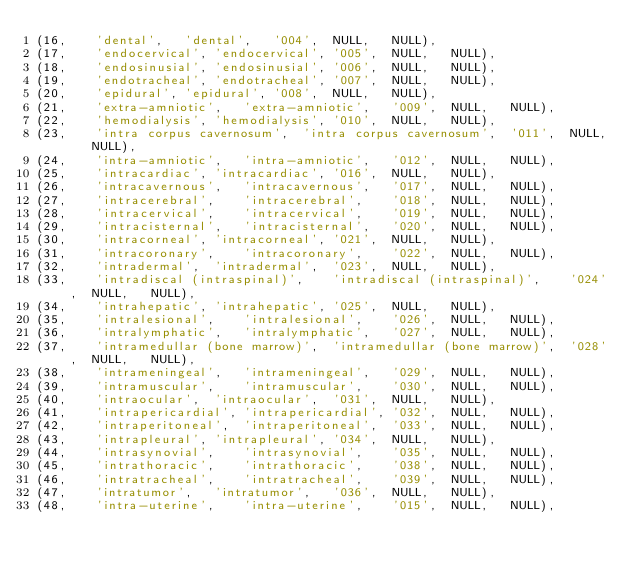<code> <loc_0><loc_0><loc_500><loc_500><_SQL_>(16,	'dental',	'dental',	'004',	NULL,	NULL),
(17,	'endocervical',	'endocervical',	'005',	NULL,	NULL),
(18,	'endosinusial',	'endosinusial',	'006',	NULL,	NULL),
(19,	'endotracheal',	'endotracheal',	'007',	NULL,	NULL),
(20,	'epidural',	'epidural',	'008',	NULL,	NULL),
(21,	'extra-amniotic',	'extra-amniotic',	'009',	NULL,	NULL),
(22,	'hemodialysis',	'hemodialysis',	'010',	NULL,	NULL),
(23,	'intra corpus cavernosum',	'intra corpus cavernosum',	'011',	NULL,	NULL),
(24,	'intra-amniotic',	'intra-amniotic',	'012',	NULL,	NULL),
(25,	'intracardiac',	'intracardiac',	'016',	NULL,	NULL),
(26,	'intracavernous',	'intracavernous',	'017',	NULL,	NULL),
(27,	'intracerebral',	'intracerebral',	'018',	NULL,	NULL),
(28,	'intracervical',	'intracervical',	'019',	NULL,	NULL),
(29,	'intracisternal',	'intracisternal',	'020',	NULL,	NULL),
(30,	'intracorneal',	'intracorneal',	'021',	NULL,	NULL),
(31,	'intracoronary',	'intracoronary',	'022',	NULL,	NULL),
(32,	'intradermal',	'intradermal',	'023',	NULL,	NULL),
(33,	'intradiscal (intraspinal)',	'intradiscal (intraspinal)',	'024',	NULL,	NULL),
(34,	'intrahepatic',	'intrahepatic',	'025',	NULL,	NULL),
(35,	'intralesional',	'intralesional',	'026',	NULL,	NULL),
(36,	'intralymphatic',	'intralymphatic',	'027',	NULL,	NULL),
(37,	'intramedullar (bone marrow)',	'intramedullar (bone marrow)',	'028',	NULL,	NULL),
(38,	'intrameningeal',	'intrameningeal',	'029',	NULL,	NULL),
(39,	'intramuscular',	'intramuscular',	'030',	NULL,	NULL),
(40,	'intraocular',	'intraocular',	'031',	NULL,	NULL),
(41,	'intrapericardial',	'intrapericardial',	'032',	NULL,	NULL),
(42,	'intraperitoneal',	'intraperitoneal',	'033',	NULL,	NULL),
(43,	'intrapleural',	'intrapleural',	'034',	NULL,	NULL),
(44,	'intrasynovial',	'intrasynovial',	'035',	NULL,	NULL),
(45,	'intrathoracic',	'intrathoracic',	'038',	NULL,	NULL),
(46,	'intratracheal',	'intratracheal',	'039',	NULL,	NULL),
(47,	'intratumor',	'intratumor',	'036',	NULL,	NULL),
(48,	'intra-uterine',	'intra-uterine',	'015',	NULL,	NULL),</code> 